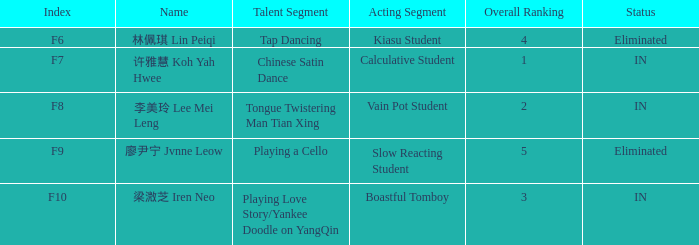For every occurrence with index f10, what is the total of the overall positions? 3.0. 